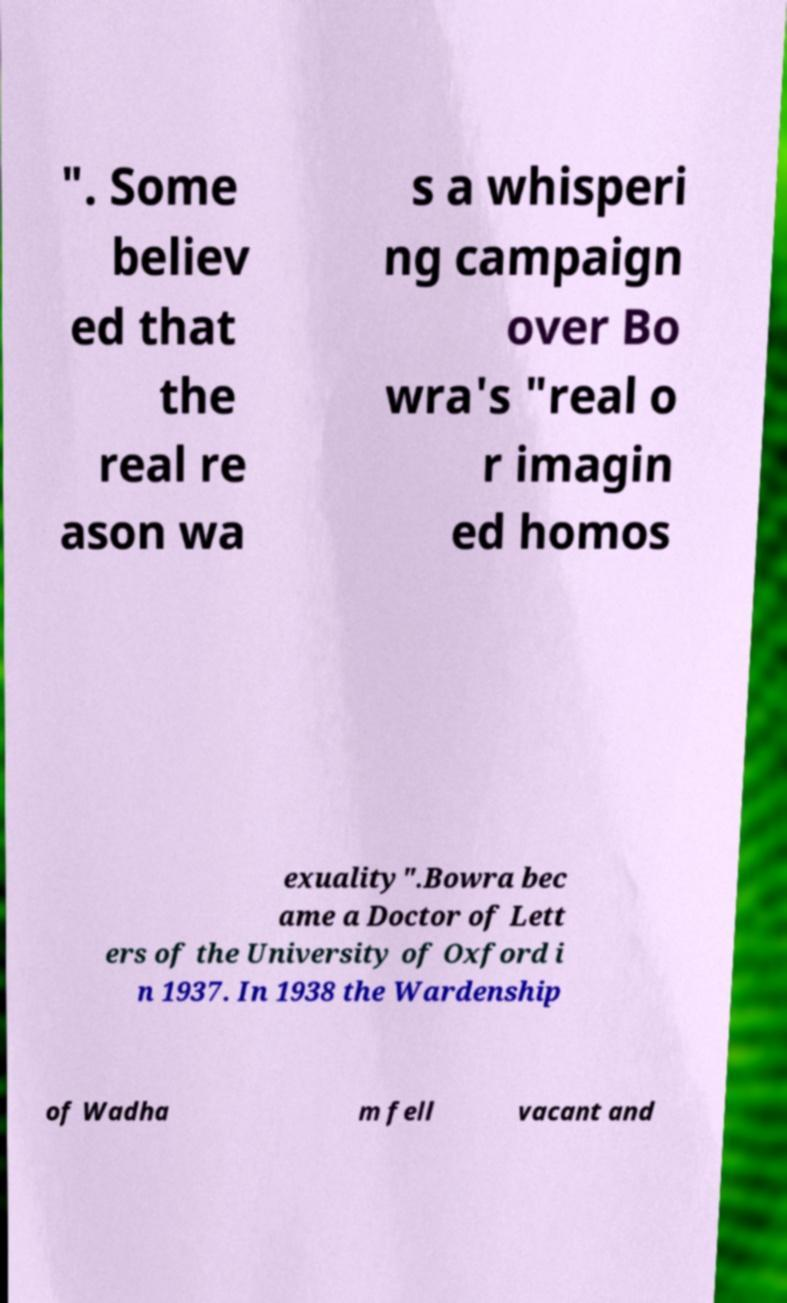What messages or text are displayed in this image? I need them in a readable, typed format. ". Some believ ed that the real re ason wa s a whisperi ng campaign over Bo wra's "real o r imagin ed homos exuality".Bowra bec ame a Doctor of Lett ers of the University of Oxford i n 1937. In 1938 the Wardenship of Wadha m fell vacant and 